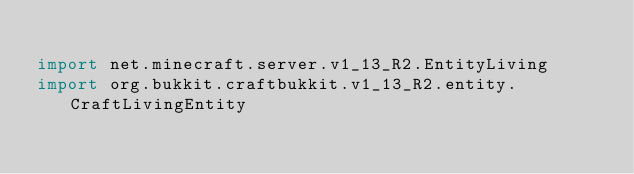<code> <loc_0><loc_0><loc_500><loc_500><_Kotlin_>
import net.minecraft.server.v1_13_R2.EntityLiving
import org.bukkit.craftbukkit.v1_13_R2.entity.CraftLivingEntity</code> 